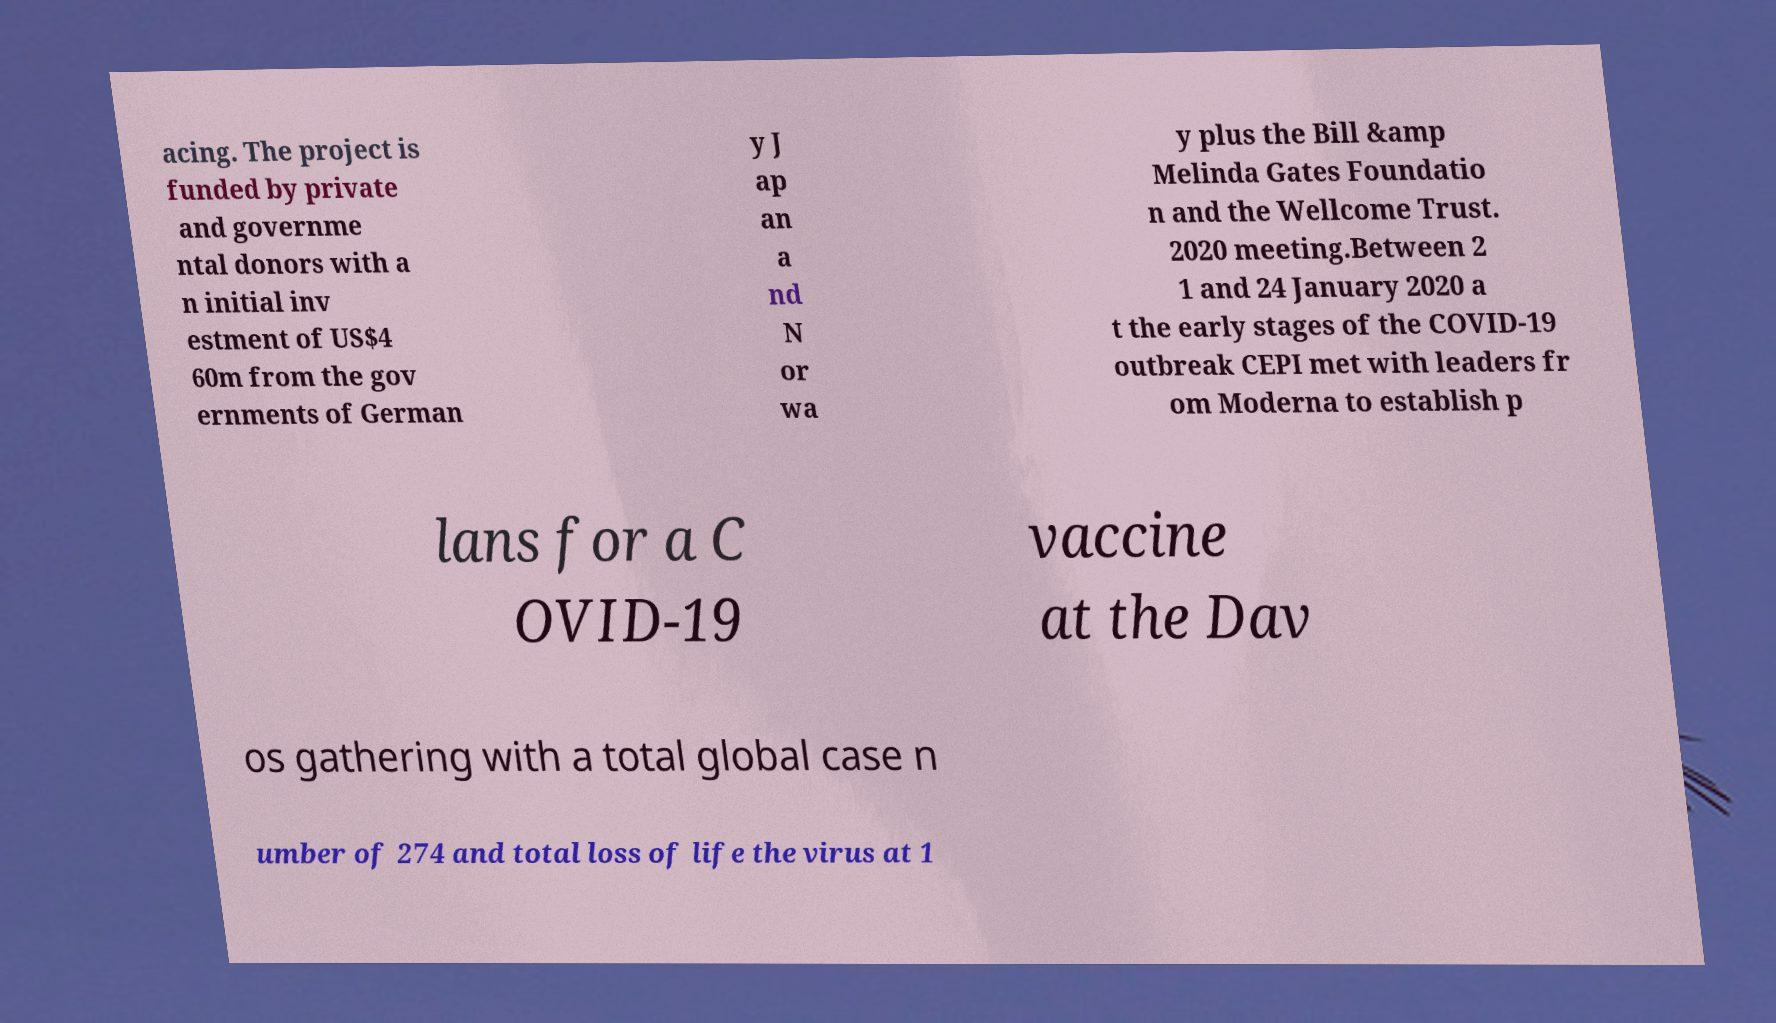For documentation purposes, I need the text within this image transcribed. Could you provide that? acing. The project is funded by private and governme ntal donors with a n initial inv estment of US$4 60m from the gov ernments of German y J ap an a nd N or wa y plus the Bill &amp Melinda Gates Foundatio n and the Wellcome Trust. 2020 meeting.Between 2 1 and 24 January 2020 a t the early stages of the COVID-19 outbreak CEPI met with leaders fr om Moderna to establish p lans for a C OVID-19 vaccine at the Dav os gathering with a total global case n umber of 274 and total loss of life the virus at 1 